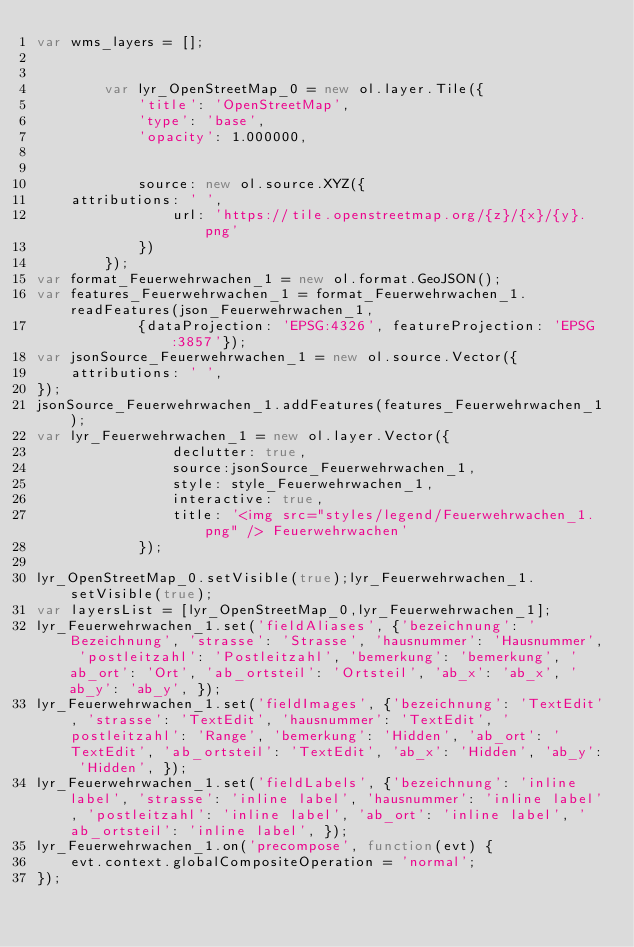Convert code to text. <code><loc_0><loc_0><loc_500><loc_500><_JavaScript_>var wms_layers = [];


        var lyr_OpenStreetMap_0 = new ol.layer.Tile({
            'title': 'OpenStreetMap',
            'type': 'base',
            'opacity': 1.000000,
            
            
            source: new ol.source.XYZ({
    attributions: ' ',
                url: 'https://tile.openstreetmap.org/{z}/{x}/{y}.png'
            })
        });
var format_Feuerwehrwachen_1 = new ol.format.GeoJSON();
var features_Feuerwehrwachen_1 = format_Feuerwehrwachen_1.readFeatures(json_Feuerwehrwachen_1, 
            {dataProjection: 'EPSG:4326', featureProjection: 'EPSG:3857'});
var jsonSource_Feuerwehrwachen_1 = new ol.source.Vector({
    attributions: ' ',
});
jsonSource_Feuerwehrwachen_1.addFeatures(features_Feuerwehrwachen_1);
var lyr_Feuerwehrwachen_1 = new ol.layer.Vector({
                declutter: true,
                source:jsonSource_Feuerwehrwachen_1, 
                style: style_Feuerwehrwachen_1,
                interactive: true,
                title: '<img src="styles/legend/Feuerwehrwachen_1.png" /> Feuerwehrwachen'
            });

lyr_OpenStreetMap_0.setVisible(true);lyr_Feuerwehrwachen_1.setVisible(true);
var layersList = [lyr_OpenStreetMap_0,lyr_Feuerwehrwachen_1];
lyr_Feuerwehrwachen_1.set('fieldAliases', {'bezeichnung': 'Bezeichnung', 'strasse': 'Strasse', 'hausnummer': 'Hausnummer', 'postleitzahl': 'Postleitzahl', 'bemerkung': 'bemerkung', 'ab_ort': 'Ort', 'ab_ortsteil': 'Ortsteil', 'ab_x': 'ab_x', 'ab_y': 'ab_y', });
lyr_Feuerwehrwachen_1.set('fieldImages', {'bezeichnung': 'TextEdit', 'strasse': 'TextEdit', 'hausnummer': 'TextEdit', 'postleitzahl': 'Range', 'bemerkung': 'Hidden', 'ab_ort': 'TextEdit', 'ab_ortsteil': 'TextEdit', 'ab_x': 'Hidden', 'ab_y': 'Hidden', });
lyr_Feuerwehrwachen_1.set('fieldLabels', {'bezeichnung': 'inline label', 'strasse': 'inline label', 'hausnummer': 'inline label', 'postleitzahl': 'inline label', 'ab_ort': 'inline label', 'ab_ortsteil': 'inline label', });
lyr_Feuerwehrwachen_1.on('precompose', function(evt) {
    evt.context.globalCompositeOperation = 'normal';
});</code> 